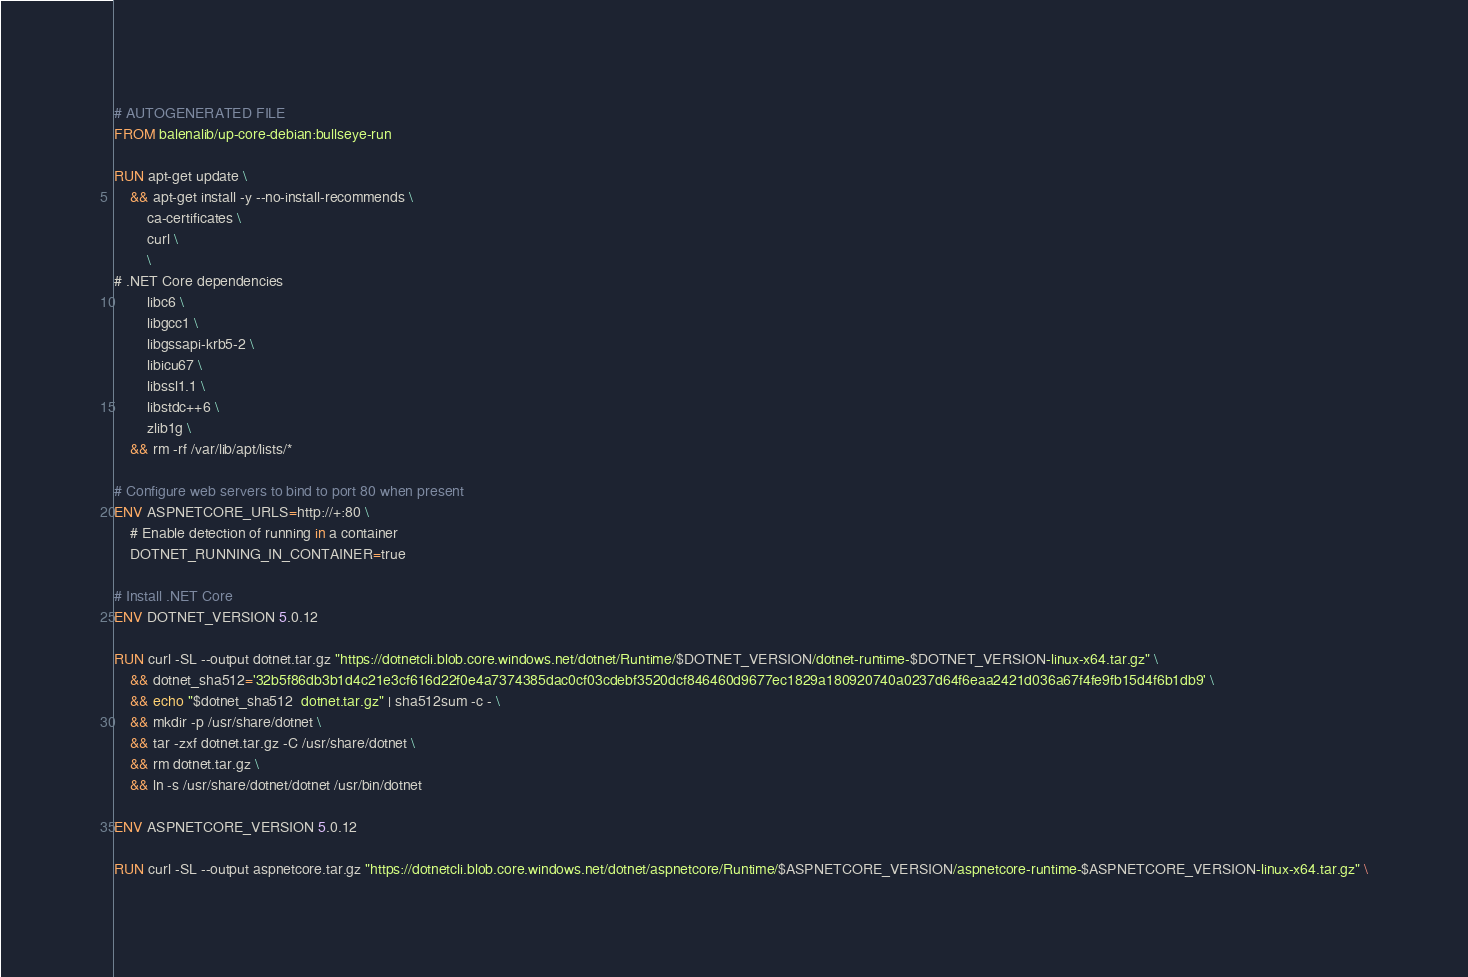<code> <loc_0><loc_0><loc_500><loc_500><_Dockerfile_># AUTOGENERATED FILE
FROM balenalib/up-core-debian:bullseye-run

RUN apt-get update \
    && apt-get install -y --no-install-recommends \
        ca-certificates \
        curl \
        \
# .NET Core dependencies
        libc6 \
        libgcc1 \
        libgssapi-krb5-2 \
        libicu67 \
        libssl1.1 \
        libstdc++6 \
        zlib1g \
    && rm -rf /var/lib/apt/lists/*

# Configure web servers to bind to port 80 when present
ENV ASPNETCORE_URLS=http://+:80 \
    # Enable detection of running in a container
    DOTNET_RUNNING_IN_CONTAINER=true

# Install .NET Core
ENV DOTNET_VERSION 5.0.12

RUN curl -SL --output dotnet.tar.gz "https://dotnetcli.blob.core.windows.net/dotnet/Runtime/$DOTNET_VERSION/dotnet-runtime-$DOTNET_VERSION-linux-x64.tar.gz" \
    && dotnet_sha512='32b5f86db3b1d4c21e3cf616d22f0e4a7374385dac0cf03cdebf3520dcf846460d9677ec1829a180920740a0237d64f6eaa2421d036a67f4fe9fb15d4f6b1db9' \
    && echo "$dotnet_sha512  dotnet.tar.gz" | sha512sum -c - \
    && mkdir -p /usr/share/dotnet \
    && tar -zxf dotnet.tar.gz -C /usr/share/dotnet \
    && rm dotnet.tar.gz \
    && ln -s /usr/share/dotnet/dotnet /usr/bin/dotnet

ENV ASPNETCORE_VERSION 5.0.12

RUN curl -SL --output aspnetcore.tar.gz "https://dotnetcli.blob.core.windows.net/dotnet/aspnetcore/Runtime/$ASPNETCORE_VERSION/aspnetcore-runtime-$ASPNETCORE_VERSION-linux-x64.tar.gz" \</code> 